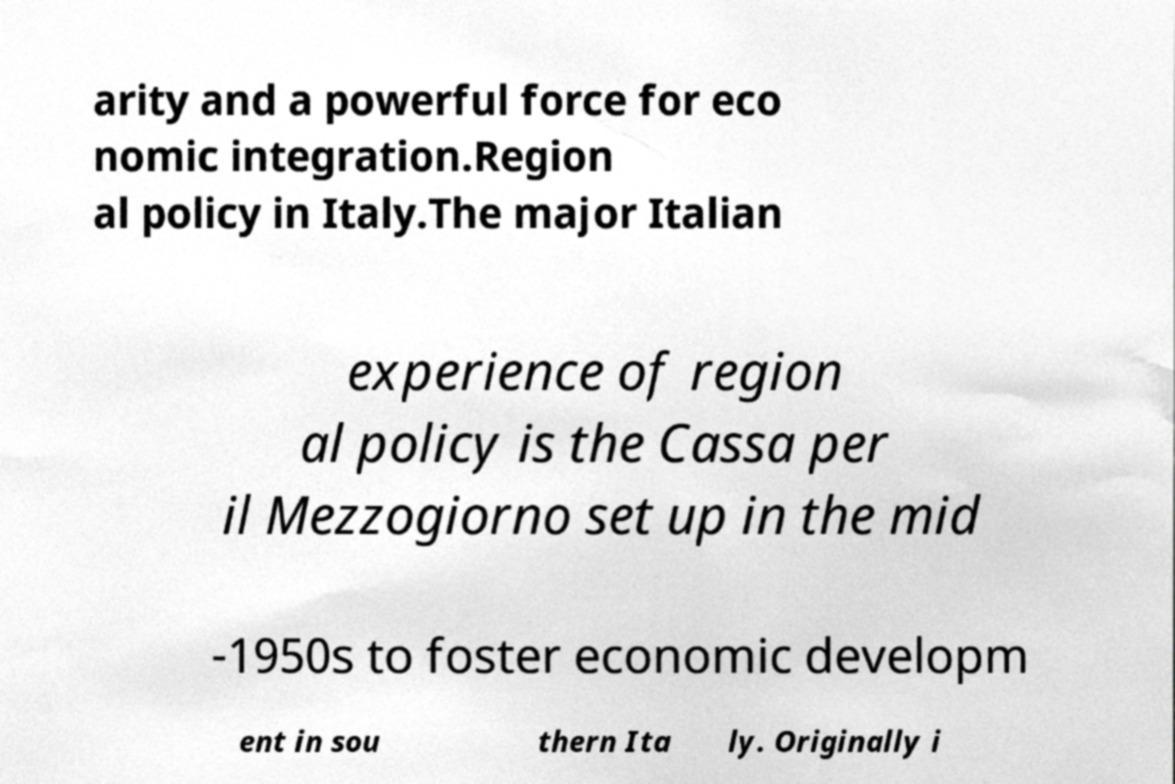Please identify and transcribe the text found in this image. arity and a powerful force for eco nomic integration.Region al policy in Italy.The major Italian experience of region al policy is the Cassa per il Mezzogiorno set up in the mid -1950s to foster economic developm ent in sou thern Ita ly. Originally i 